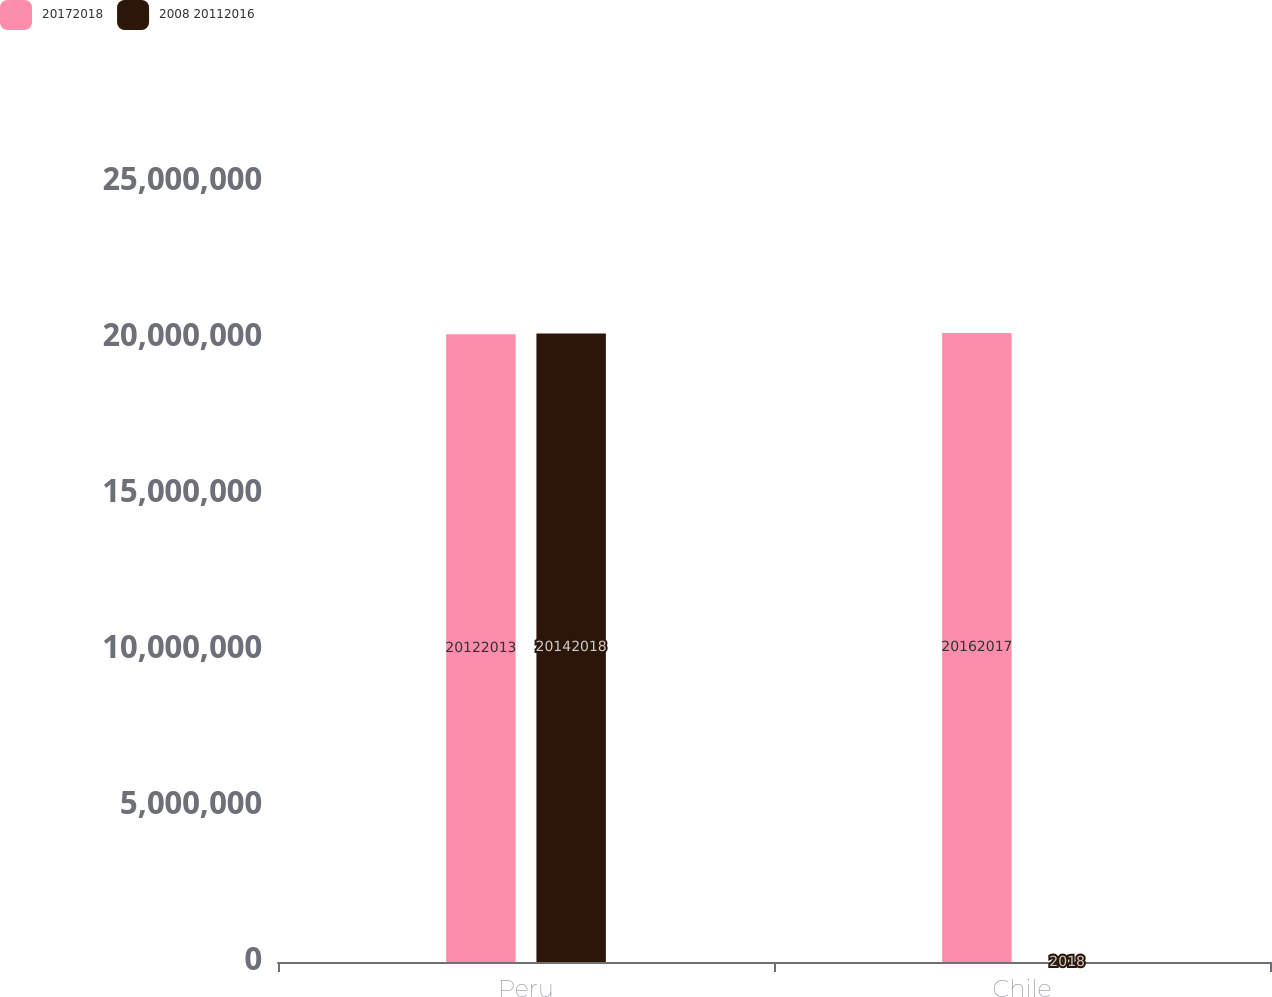Convert chart to OTSL. <chart><loc_0><loc_0><loc_500><loc_500><stacked_bar_chart><ecel><fcel>Peru<fcel>Chile<nl><fcel>20172018<fcel>2.0122e+07<fcel>2.0162e+07<nl><fcel>2008 20112016<fcel>2.0142e+07<fcel>2018<nl></chart> 